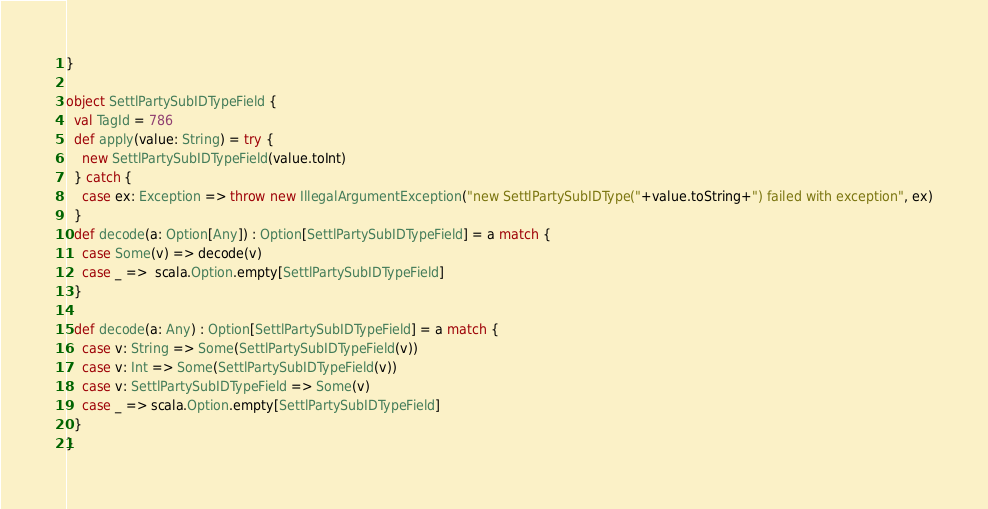Convert code to text. <code><loc_0><loc_0><loc_500><loc_500><_Scala_>}

object SettlPartySubIDTypeField {
  val TagId = 786  
  def apply(value: String) = try {
    new SettlPartySubIDTypeField(value.toInt)
  } catch {
    case ex: Exception => throw new IllegalArgumentException("new SettlPartySubIDType("+value.toString+") failed with exception", ex)
  } 
  def decode(a: Option[Any]) : Option[SettlPartySubIDTypeField] = a match {
    case Some(v) => decode(v)
    case _ =>  scala.Option.empty[SettlPartySubIDTypeField]
  }

  def decode(a: Any) : Option[SettlPartySubIDTypeField] = a match {
    case v: String => Some(SettlPartySubIDTypeField(v))
    case v: Int => Some(SettlPartySubIDTypeField(v))
    case v: SettlPartySubIDTypeField => Some(v)
    case _ => scala.Option.empty[SettlPartySubIDTypeField]
  } 
}
</code> 